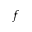<formula> <loc_0><loc_0><loc_500><loc_500>f</formula> 